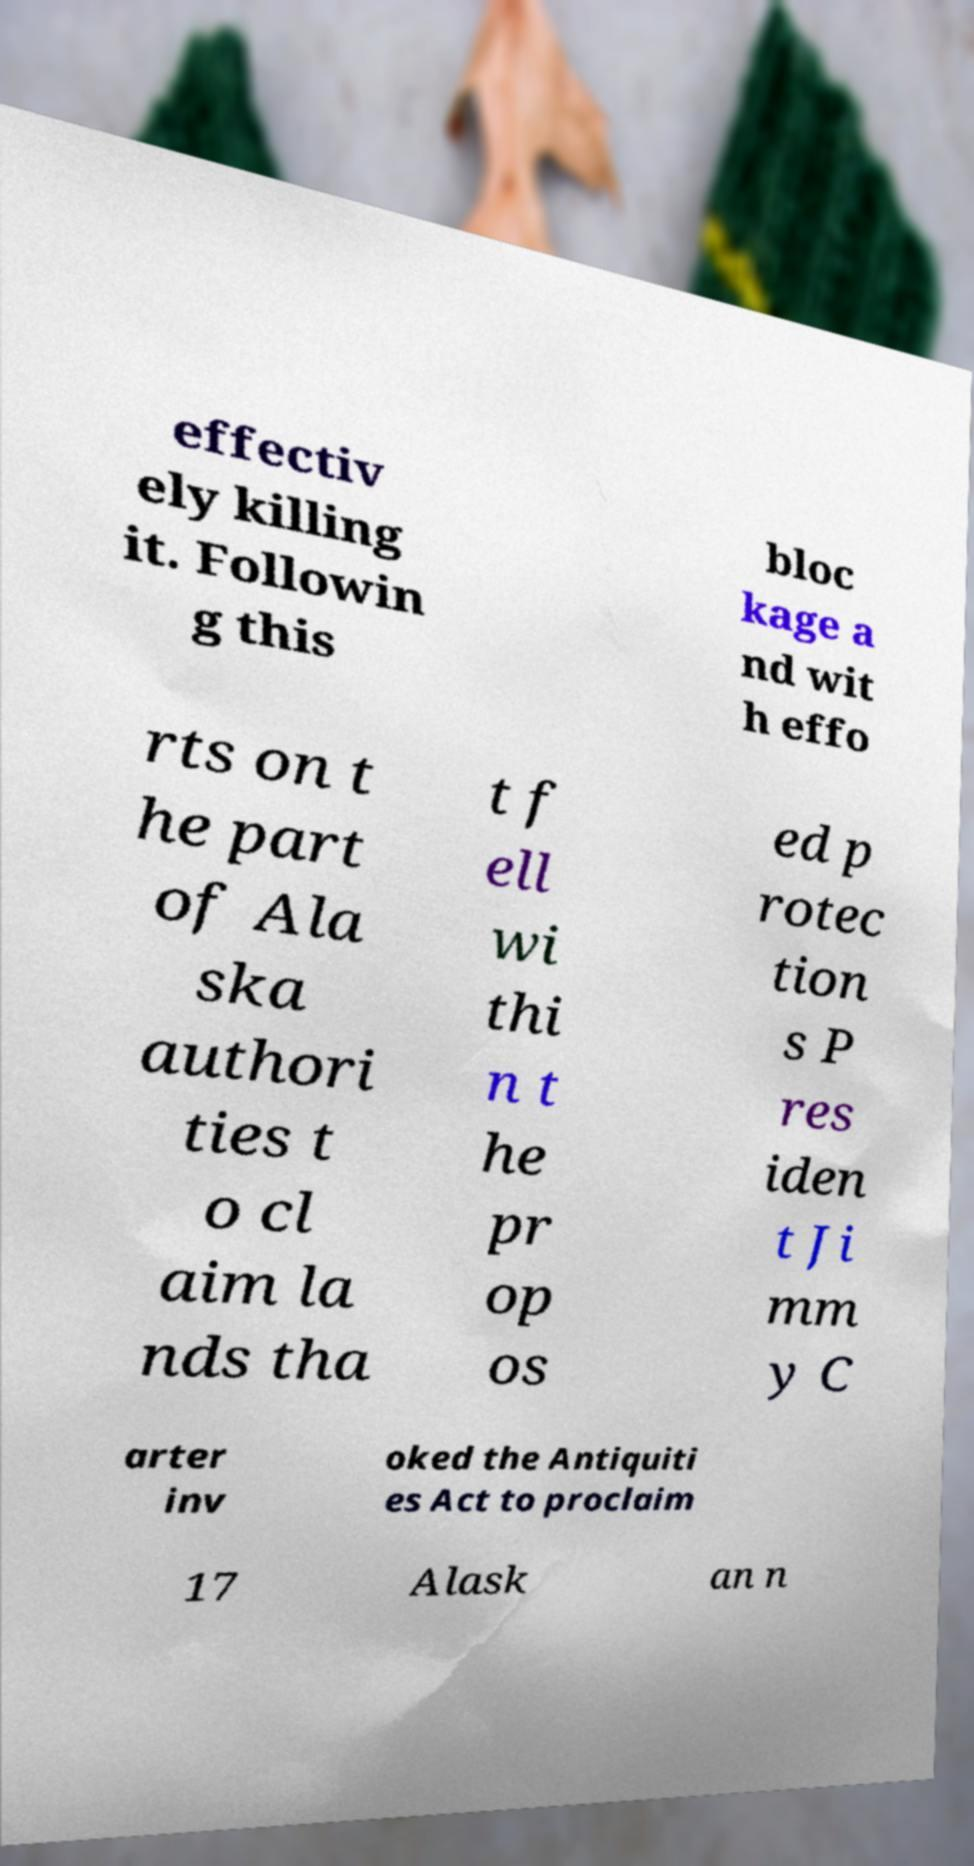What messages or text are displayed in this image? I need them in a readable, typed format. effectiv ely killing it. Followin g this bloc kage a nd wit h effo rts on t he part of Ala ska authori ties t o cl aim la nds tha t f ell wi thi n t he pr op os ed p rotec tion s P res iden t Ji mm y C arter inv oked the Antiquiti es Act to proclaim 17 Alask an n 